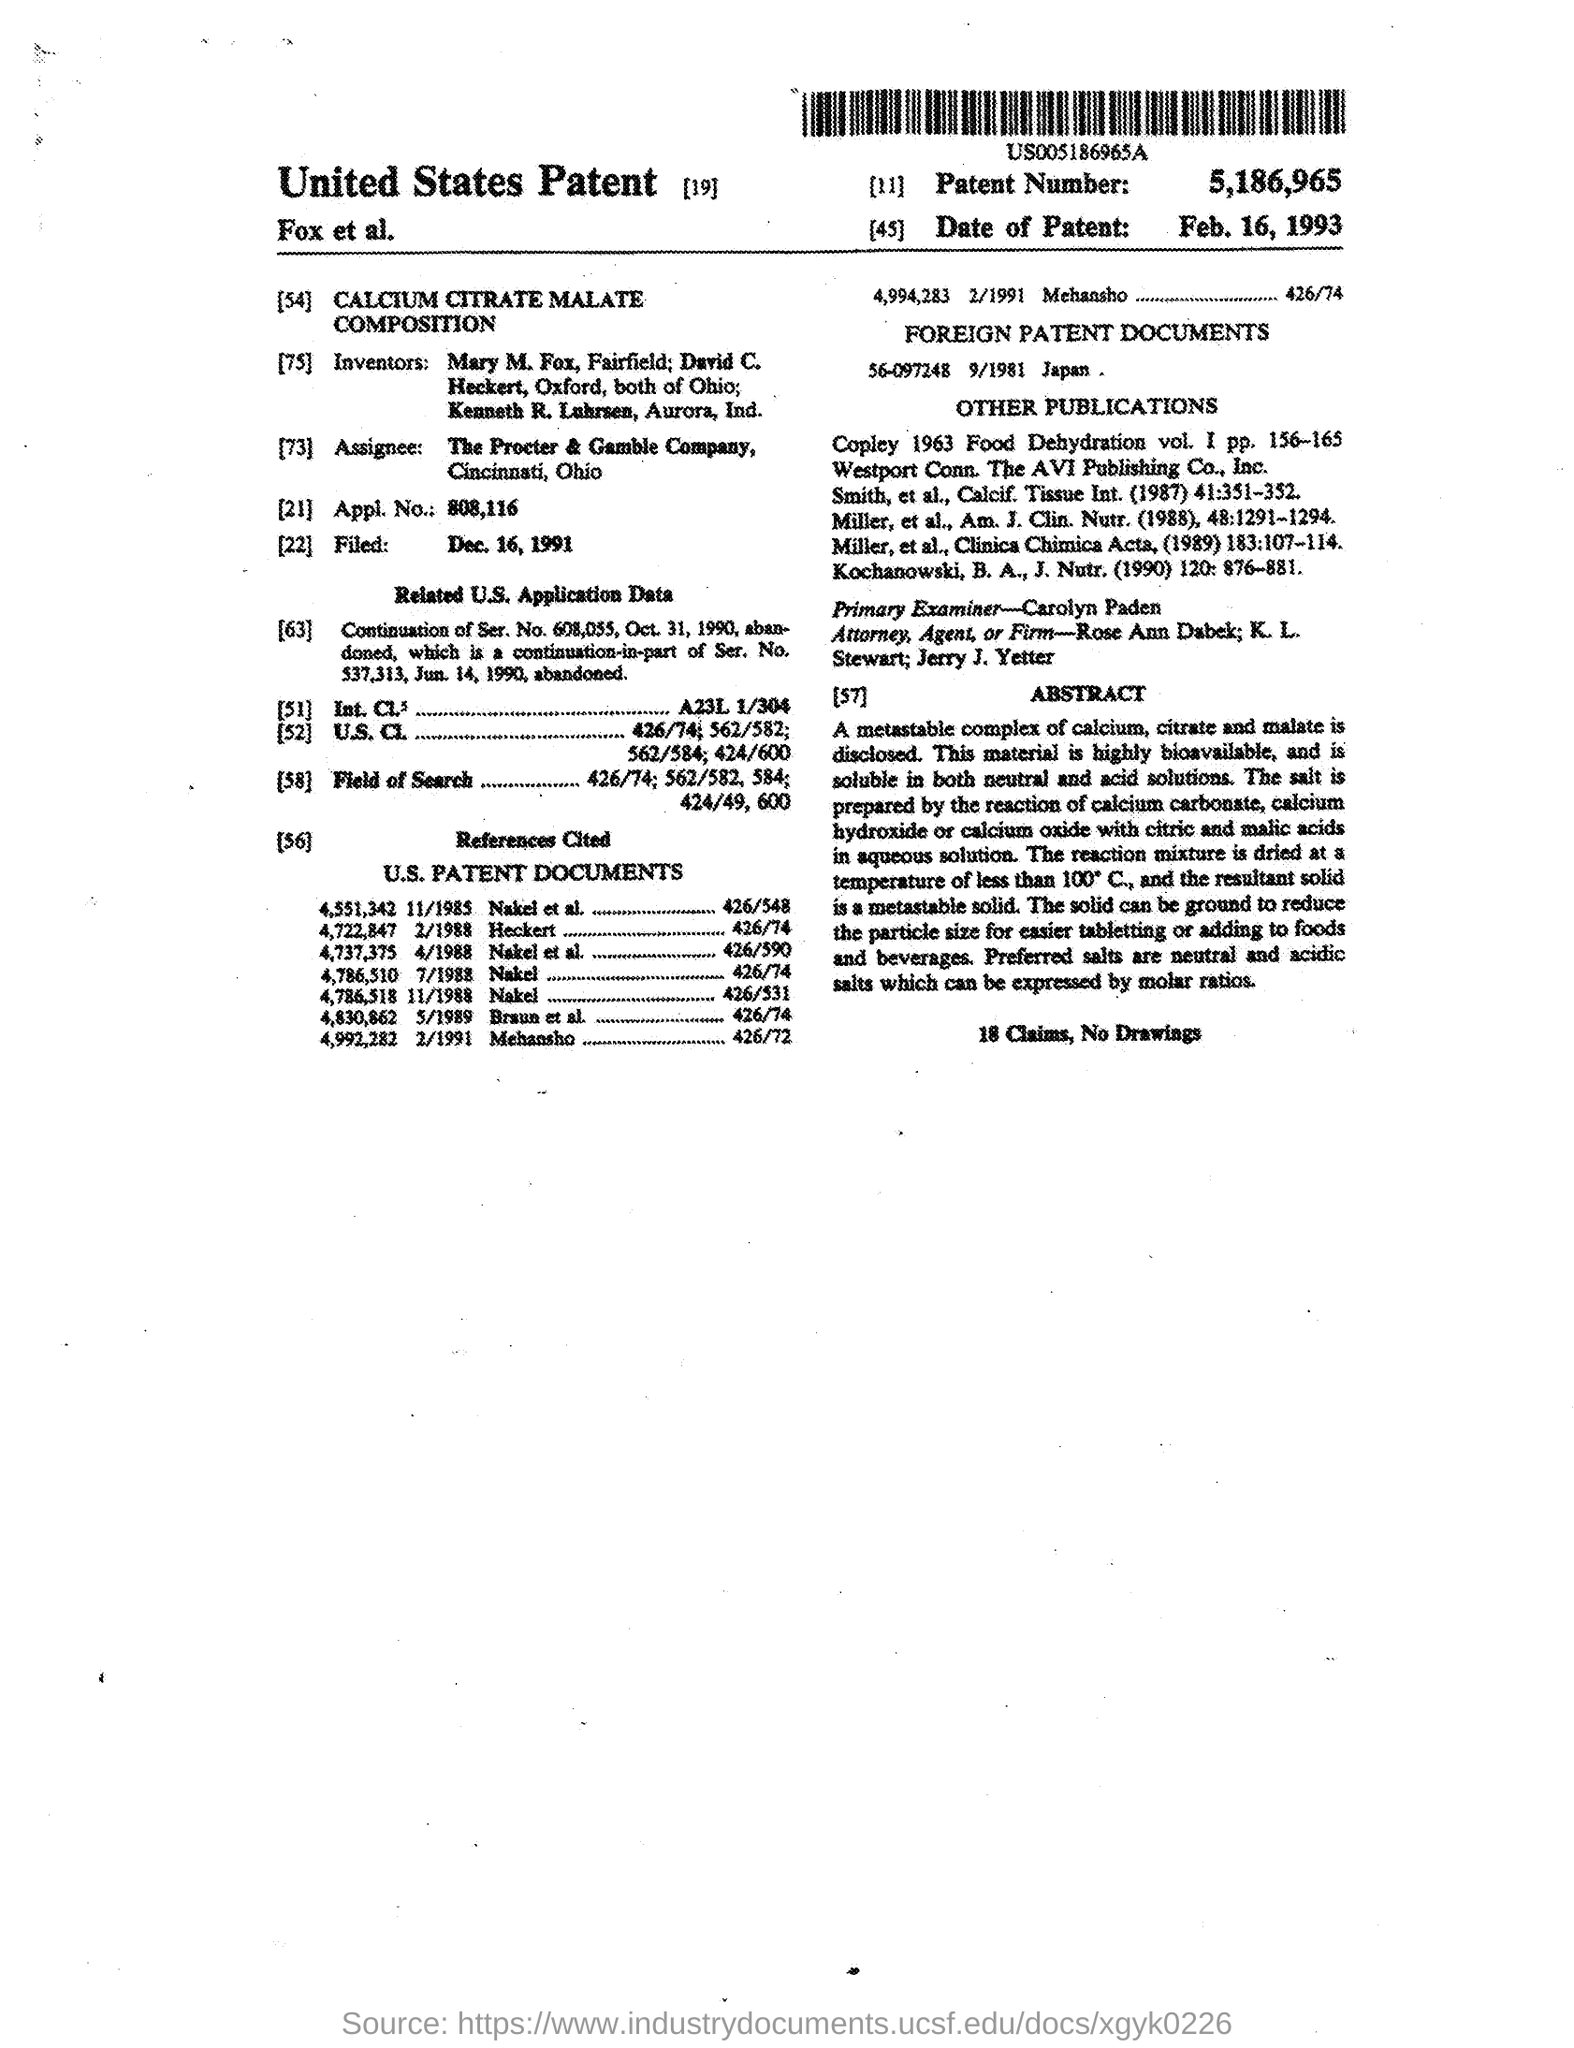Indicate a few pertinent items in this graphic. Carolyn Paden was the primary examiner. This salt is soluble in both neutral and acid solutions. The foreign patent document is 56-097248 from Japan, issued on September 1981. The practice sizes for the tablet compression method have been reduced to facilitate easier tabletting or incorporation into food and beverages. The patent number is 5,186,965. 